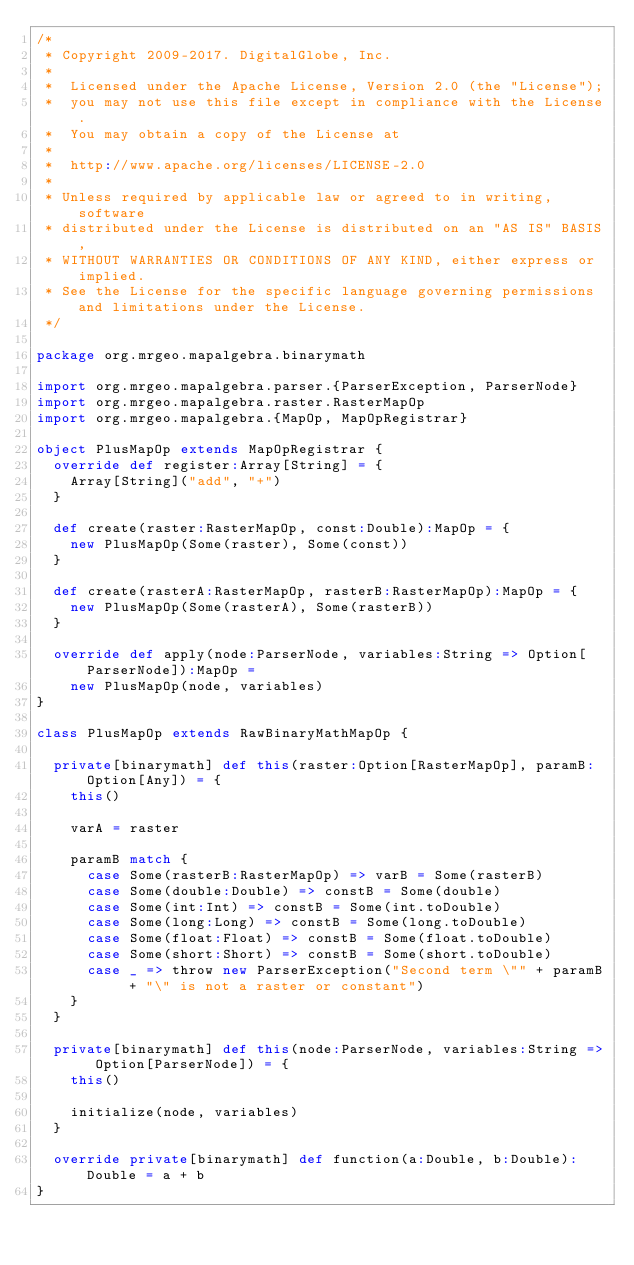Convert code to text. <code><loc_0><loc_0><loc_500><loc_500><_Scala_>/*
 * Copyright 2009-2017. DigitalGlobe, Inc.
 *
 *  Licensed under the Apache License, Version 2.0 (the "License");
 *  you may not use this file except in compliance with the License.
 *  You may obtain a copy of the License at
 *
 *  http://www.apache.org/licenses/LICENSE-2.0
 *
 * Unless required by applicable law or agreed to in writing, software
 * distributed under the License is distributed on an "AS IS" BASIS,
 * WITHOUT WARRANTIES OR CONDITIONS OF ANY KIND, either express or implied.
 * See the License for the specific language governing permissions and limitations under the License.
 */

package org.mrgeo.mapalgebra.binarymath

import org.mrgeo.mapalgebra.parser.{ParserException, ParserNode}
import org.mrgeo.mapalgebra.raster.RasterMapOp
import org.mrgeo.mapalgebra.{MapOp, MapOpRegistrar}

object PlusMapOp extends MapOpRegistrar {
  override def register:Array[String] = {
    Array[String]("add", "+")
  }

  def create(raster:RasterMapOp, const:Double):MapOp = {
    new PlusMapOp(Some(raster), Some(const))
  }

  def create(rasterA:RasterMapOp, rasterB:RasterMapOp):MapOp = {
    new PlusMapOp(Some(rasterA), Some(rasterB))
  }

  override def apply(node:ParserNode, variables:String => Option[ParserNode]):MapOp =
    new PlusMapOp(node, variables)
}

class PlusMapOp extends RawBinaryMathMapOp {

  private[binarymath] def this(raster:Option[RasterMapOp], paramB:Option[Any]) = {
    this()

    varA = raster

    paramB match {
      case Some(rasterB:RasterMapOp) => varB = Some(rasterB)
      case Some(double:Double) => constB = Some(double)
      case Some(int:Int) => constB = Some(int.toDouble)
      case Some(long:Long) => constB = Some(long.toDouble)
      case Some(float:Float) => constB = Some(float.toDouble)
      case Some(short:Short) => constB = Some(short.toDouble)
      case _ => throw new ParserException("Second term \"" + paramB + "\" is not a raster or constant")
    }
  }

  private[binarymath] def this(node:ParserNode, variables:String => Option[ParserNode]) = {
    this()

    initialize(node, variables)
  }

  override private[binarymath] def function(a:Double, b:Double):Double = a + b
}
</code> 